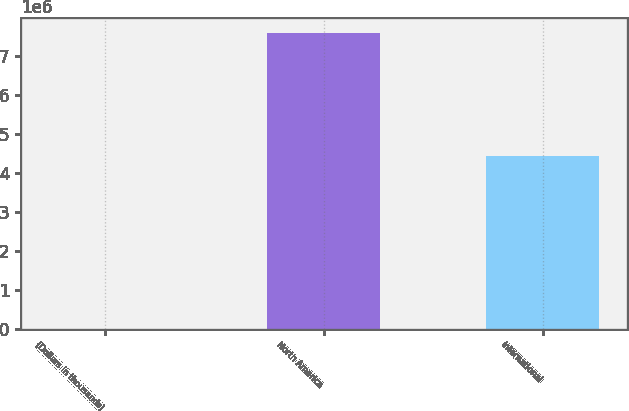Convert chart to OTSL. <chart><loc_0><loc_0><loc_500><loc_500><bar_chart><fcel>(Dollars in thousands)<fcel>North America<fcel>International<nl><fcel>2017<fcel>7.58569e+06<fcel>4.44362e+06<nl></chart> 